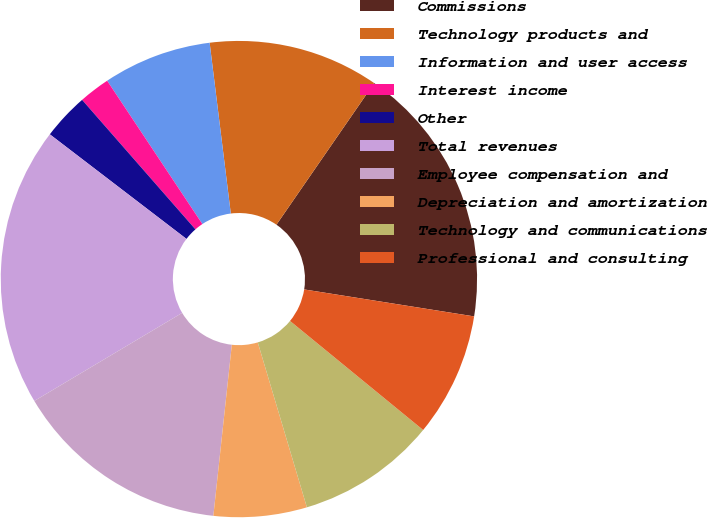Convert chart to OTSL. <chart><loc_0><loc_0><loc_500><loc_500><pie_chart><fcel>Commissions<fcel>Technology products and<fcel>Information and user access<fcel>Interest income<fcel>Other<fcel>Total revenues<fcel>Employee compensation and<fcel>Depreciation and amortization<fcel>Technology and communications<fcel>Professional and consulting<nl><fcel>17.89%<fcel>11.58%<fcel>7.37%<fcel>2.11%<fcel>3.16%<fcel>18.95%<fcel>14.74%<fcel>6.32%<fcel>9.47%<fcel>8.42%<nl></chart> 